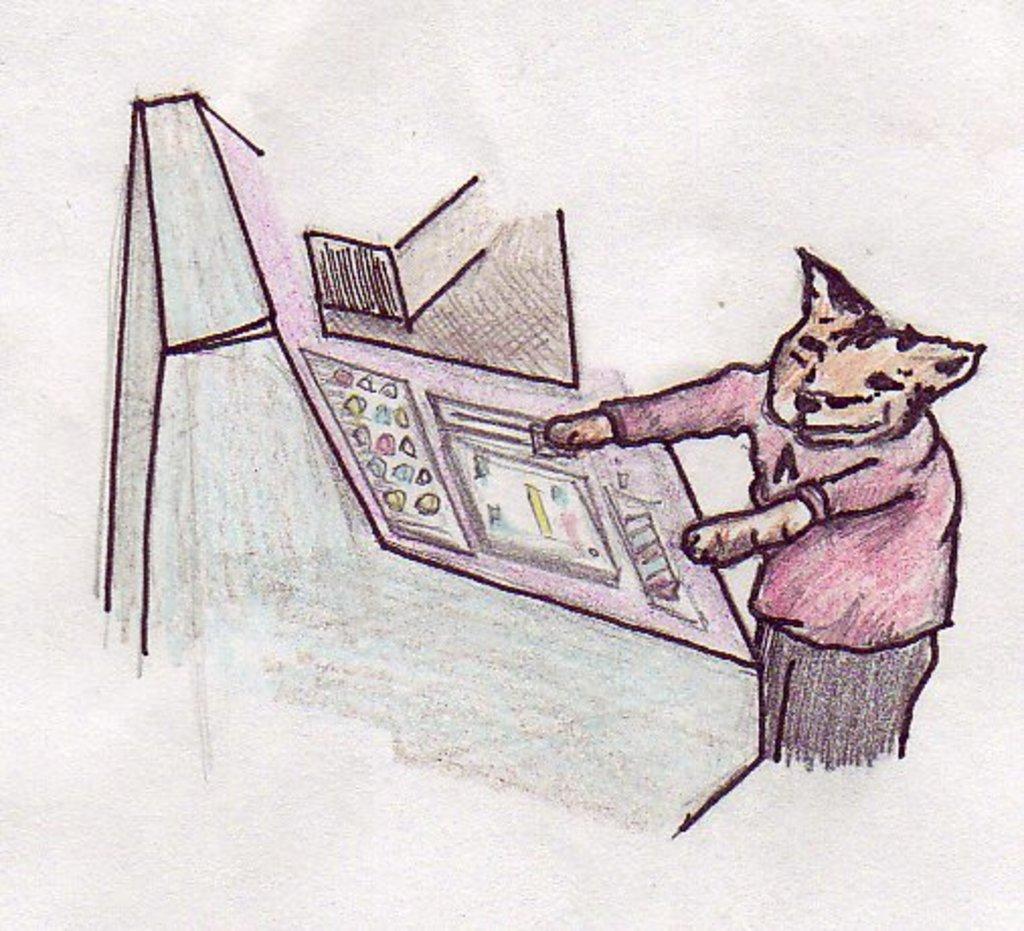How would you summarize this image in a sentence or two? This image consists of a drawing. On the right, it looks like an animal. 